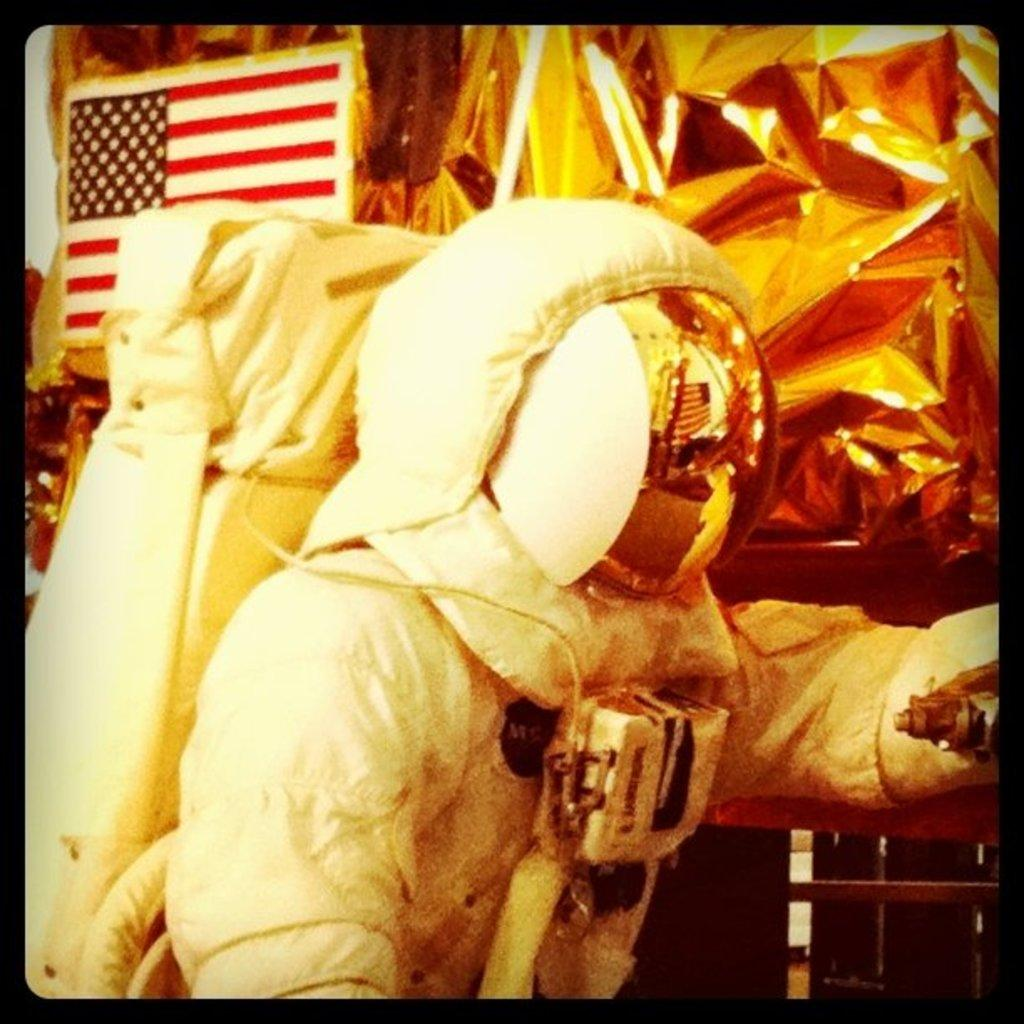Who is the main subject in the image? There is a person in the center of the image. What is the person wearing? The person is wearing a costume. What can be seen in the background of the image? There are covers and a flag in the background of the image. Are there any other objects visible in the background? Yes, there are other objects present in the background of the image. Can you see the person's friend through the window in the image? There is no window present in the image, and therefore no friend can be seen through it. 